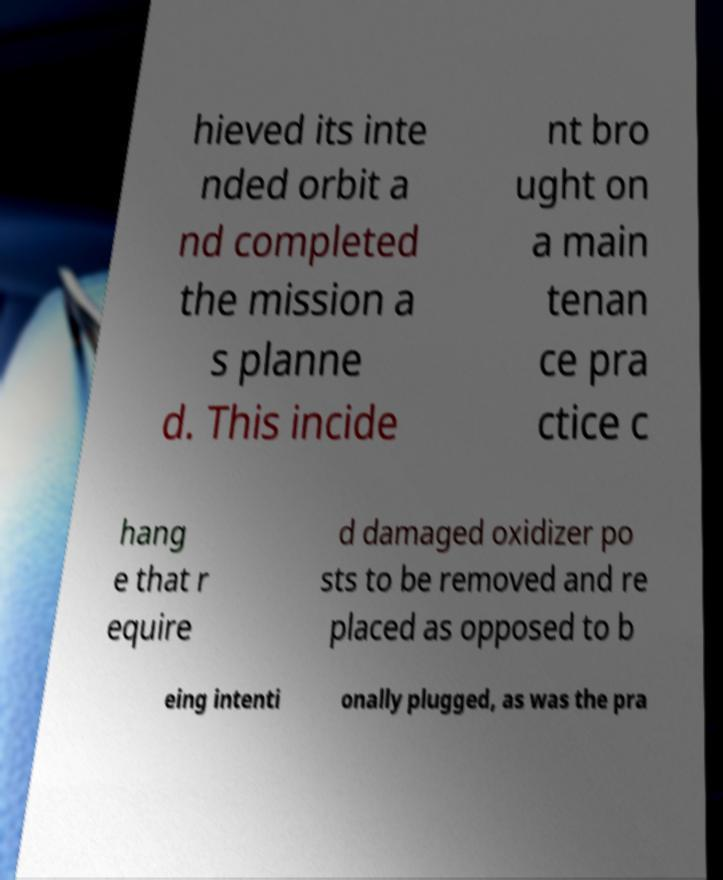Can you read and provide the text displayed in the image?This photo seems to have some interesting text. Can you extract and type it out for me? hieved its inte nded orbit a nd completed the mission a s planne d. This incide nt bro ught on a main tenan ce pra ctice c hang e that r equire d damaged oxidizer po sts to be removed and re placed as opposed to b eing intenti onally plugged, as was the pra 